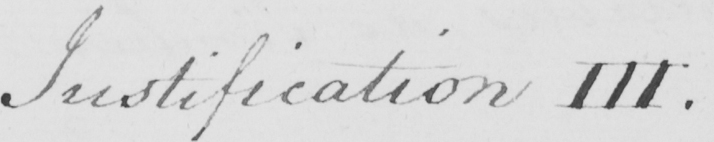What text is written in this handwritten line? Justification III . 